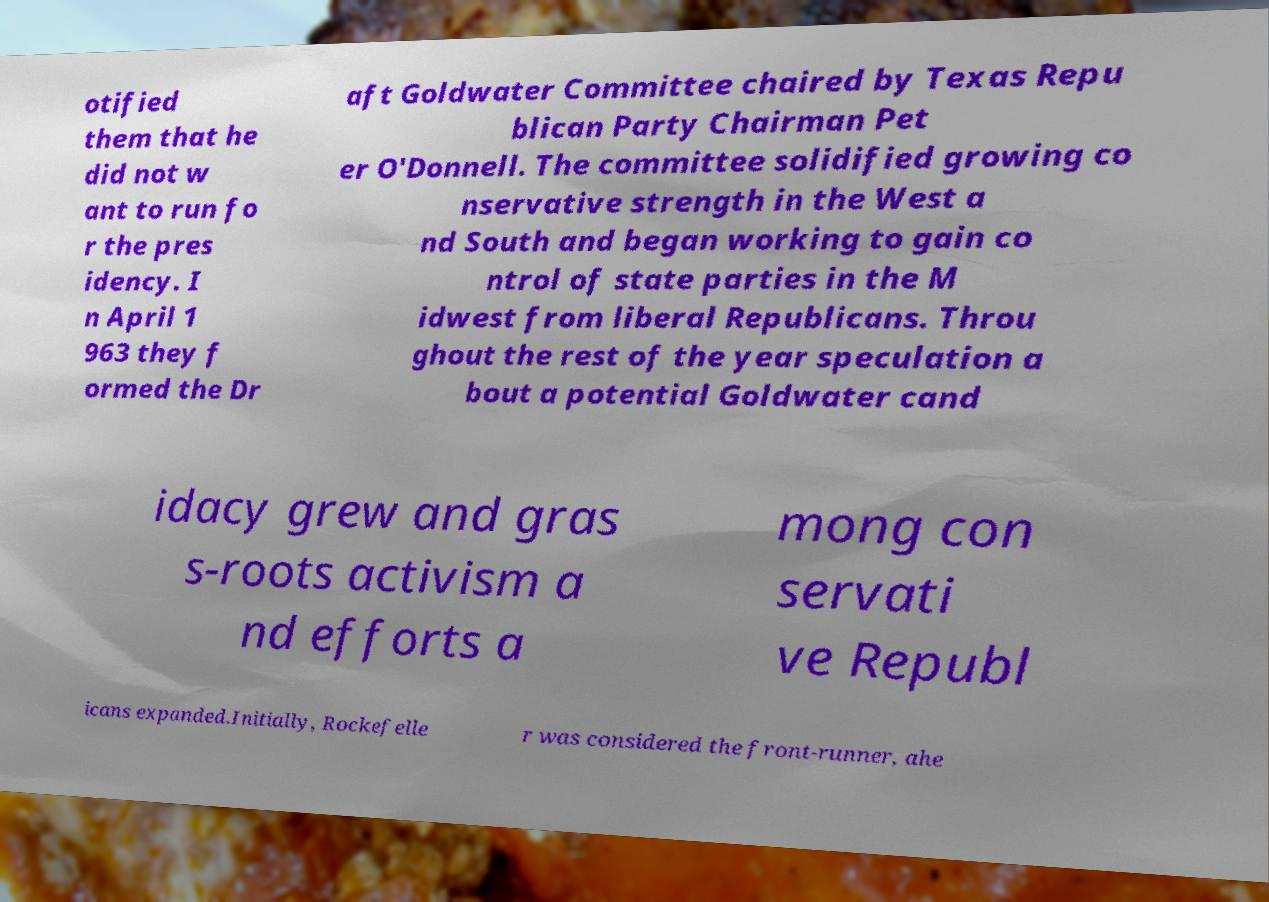For documentation purposes, I need the text within this image transcribed. Could you provide that? otified them that he did not w ant to run fo r the pres idency. I n April 1 963 they f ormed the Dr aft Goldwater Committee chaired by Texas Repu blican Party Chairman Pet er O'Donnell. The committee solidified growing co nservative strength in the West a nd South and began working to gain co ntrol of state parties in the M idwest from liberal Republicans. Throu ghout the rest of the year speculation a bout a potential Goldwater cand idacy grew and gras s-roots activism a nd efforts a mong con servati ve Republ icans expanded.Initially, Rockefelle r was considered the front-runner, ahe 